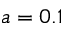Convert formula to latex. <formula><loc_0><loc_0><loc_500><loc_500>a = 0 . 1</formula> 